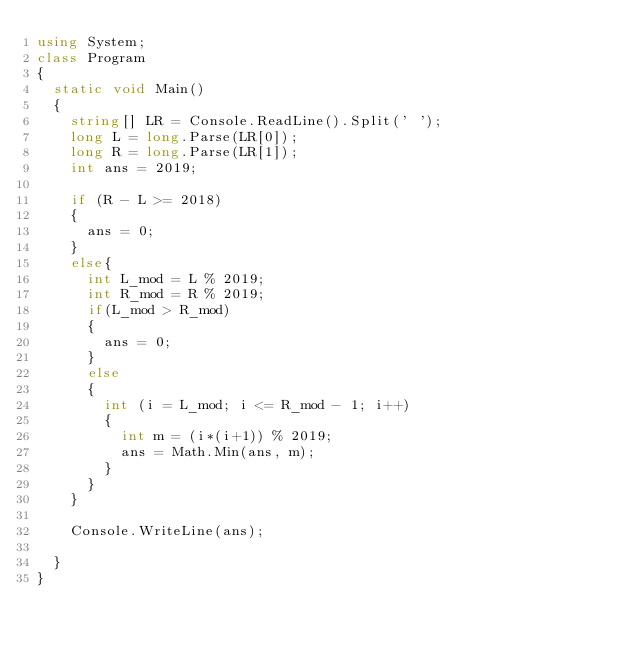Convert code to text. <code><loc_0><loc_0><loc_500><loc_500><_C#_>using System;
class Program
{
  static void Main()
  {
    string[] LR = Console.ReadLine().Split(' ');
    long L = long.Parse(LR[0]);
    long R = long.Parse(LR[1]);
    int ans = 2019;
    
    if (R - L >= 2018)
    {
      ans = 0;
    }
    else{
      int L_mod = L % 2019;
      int R_mod = R % 2019;
      if(L_mod > R_mod)
      {
        ans = 0;
      }
      else
      {
        int (i = L_mod; i <= R_mod - 1; i++)
        {
          int m = (i*(i+1)) % 2019;
          ans = Math.Min(ans, m);
        }
      }
    }
    
    Console.WriteLine(ans);
    
  }
}</code> 